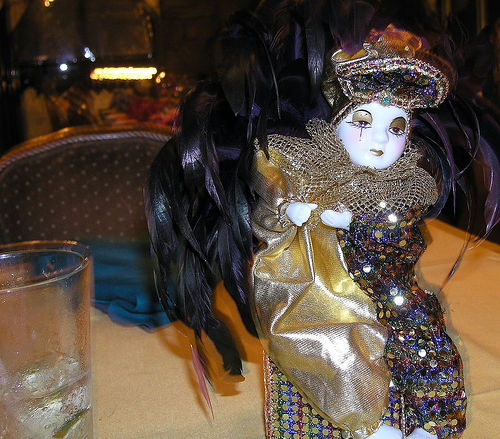<image>
Is the doll above the table? No. The doll is not positioned above the table. The vertical arrangement shows a different relationship. 